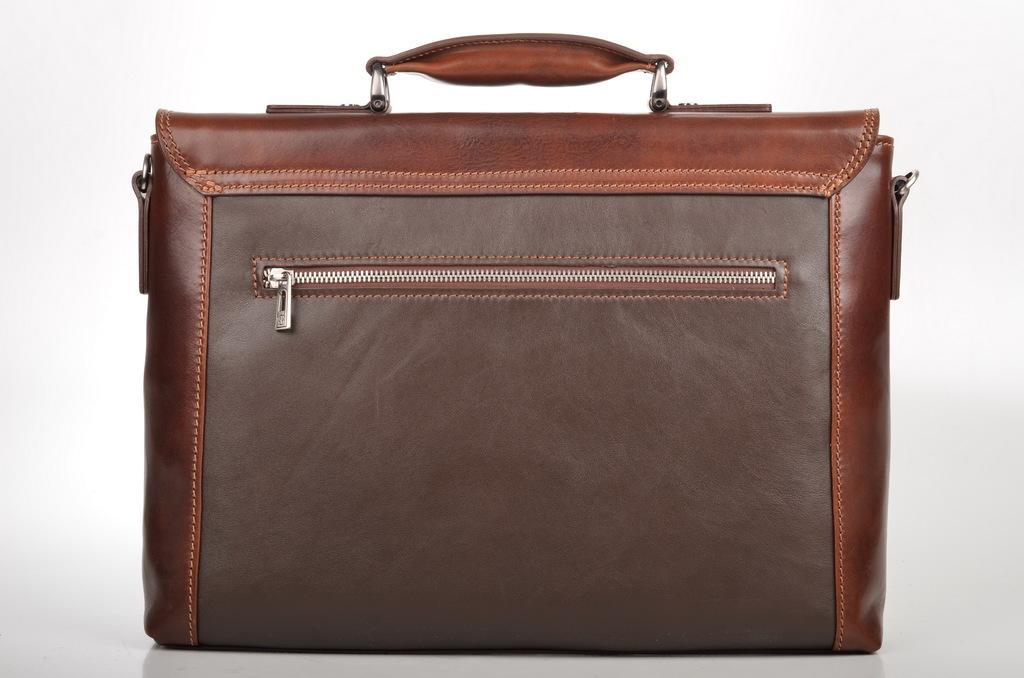Describe this image in one or two sentences. In this picture we can see a bag. 